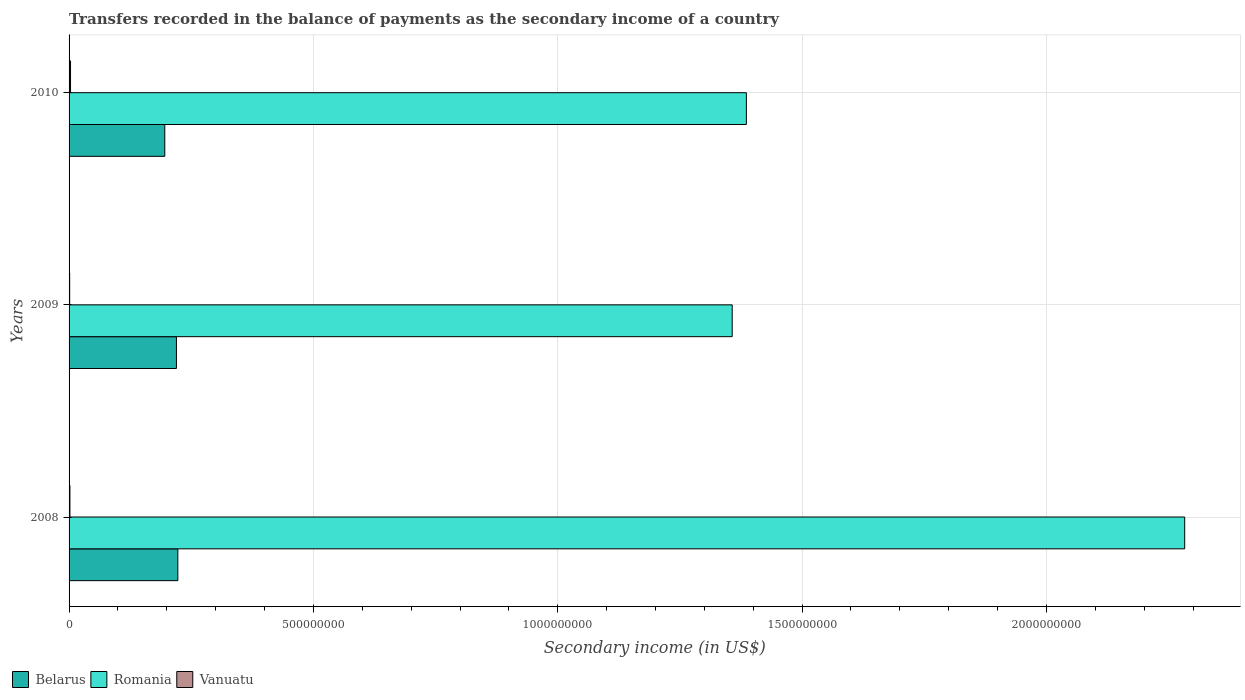How many groups of bars are there?
Give a very brief answer. 3. Are the number of bars per tick equal to the number of legend labels?
Your answer should be compact. Yes. Are the number of bars on each tick of the Y-axis equal?
Provide a short and direct response. Yes. How many bars are there on the 3rd tick from the top?
Provide a short and direct response. 3. What is the label of the 3rd group of bars from the top?
Ensure brevity in your answer.  2008. What is the secondary income of in Romania in 2008?
Your answer should be compact. 2.28e+09. Across all years, what is the maximum secondary income of in Vanuatu?
Your answer should be compact. 2.99e+06. Across all years, what is the minimum secondary income of in Vanuatu?
Offer a very short reply. 1.23e+06. In which year was the secondary income of in Romania maximum?
Provide a short and direct response. 2008. What is the total secondary income of in Romania in the graph?
Make the answer very short. 5.03e+09. What is the difference between the secondary income of in Vanuatu in 2008 and that in 2010?
Keep it short and to the point. -1.26e+06. What is the difference between the secondary income of in Vanuatu in 2009 and the secondary income of in Belarus in 2008?
Your answer should be very brief. -2.21e+08. What is the average secondary income of in Romania per year?
Make the answer very short. 1.68e+09. In the year 2008, what is the difference between the secondary income of in Romania and secondary income of in Belarus?
Ensure brevity in your answer.  2.06e+09. What is the ratio of the secondary income of in Vanuatu in 2008 to that in 2009?
Your answer should be very brief. 1.41. Is the difference between the secondary income of in Romania in 2008 and 2010 greater than the difference between the secondary income of in Belarus in 2008 and 2010?
Make the answer very short. Yes. What is the difference between the highest and the second highest secondary income of in Belarus?
Offer a very short reply. 2.90e+06. What is the difference between the highest and the lowest secondary income of in Vanuatu?
Offer a very short reply. 1.77e+06. In how many years, is the secondary income of in Vanuatu greater than the average secondary income of in Vanuatu taken over all years?
Give a very brief answer. 1. What does the 2nd bar from the top in 2009 represents?
Give a very brief answer. Romania. What does the 2nd bar from the bottom in 2009 represents?
Offer a terse response. Romania. Is it the case that in every year, the sum of the secondary income of in Romania and secondary income of in Belarus is greater than the secondary income of in Vanuatu?
Your response must be concise. Yes. How many years are there in the graph?
Ensure brevity in your answer.  3. What is the difference between two consecutive major ticks on the X-axis?
Offer a very short reply. 5.00e+08. Are the values on the major ticks of X-axis written in scientific E-notation?
Ensure brevity in your answer.  No. Does the graph contain any zero values?
Ensure brevity in your answer.  No. Does the graph contain grids?
Provide a succinct answer. Yes. Where does the legend appear in the graph?
Make the answer very short. Bottom left. How many legend labels are there?
Your answer should be compact. 3. What is the title of the graph?
Make the answer very short. Transfers recorded in the balance of payments as the secondary income of a country. Does "European Union" appear as one of the legend labels in the graph?
Offer a very short reply. No. What is the label or title of the X-axis?
Your answer should be very brief. Secondary income (in US$). What is the Secondary income (in US$) of Belarus in 2008?
Ensure brevity in your answer.  2.23e+08. What is the Secondary income (in US$) in Romania in 2008?
Offer a terse response. 2.28e+09. What is the Secondary income (in US$) in Vanuatu in 2008?
Provide a succinct answer. 1.73e+06. What is the Secondary income (in US$) in Belarus in 2009?
Offer a very short reply. 2.20e+08. What is the Secondary income (in US$) in Romania in 2009?
Provide a succinct answer. 1.36e+09. What is the Secondary income (in US$) in Vanuatu in 2009?
Ensure brevity in your answer.  1.23e+06. What is the Secondary income (in US$) in Belarus in 2010?
Provide a short and direct response. 1.96e+08. What is the Secondary income (in US$) in Romania in 2010?
Offer a terse response. 1.39e+09. What is the Secondary income (in US$) in Vanuatu in 2010?
Your response must be concise. 2.99e+06. Across all years, what is the maximum Secondary income (in US$) of Belarus?
Give a very brief answer. 2.23e+08. Across all years, what is the maximum Secondary income (in US$) of Romania?
Your answer should be compact. 2.28e+09. Across all years, what is the maximum Secondary income (in US$) of Vanuatu?
Provide a succinct answer. 2.99e+06. Across all years, what is the minimum Secondary income (in US$) of Belarus?
Ensure brevity in your answer.  1.96e+08. Across all years, what is the minimum Secondary income (in US$) in Romania?
Offer a very short reply. 1.36e+09. Across all years, what is the minimum Secondary income (in US$) of Vanuatu?
Your response must be concise. 1.23e+06. What is the total Secondary income (in US$) of Belarus in the graph?
Give a very brief answer. 6.38e+08. What is the total Secondary income (in US$) of Romania in the graph?
Your answer should be compact. 5.03e+09. What is the total Secondary income (in US$) of Vanuatu in the graph?
Your answer should be compact. 5.96e+06. What is the difference between the Secondary income (in US$) of Belarus in 2008 and that in 2009?
Keep it short and to the point. 2.90e+06. What is the difference between the Secondary income (in US$) in Romania in 2008 and that in 2009?
Offer a very short reply. 9.26e+08. What is the difference between the Secondary income (in US$) in Vanuatu in 2008 and that in 2009?
Give a very brief answer. 5.06e+05. What is the difference between the Secondary income (in US$) of Belarus in 2008 and that in 2010?
Your response must be concise. 2.67e+07. What is the difference between the Secondary income (in US$) in Romania in 2008 and that in 2010?
Your response must be concise. 8.97e+08. What is the difference between the Secondary income (in US$) in Vanuatu in 2008 and that in 2010?
Provide a short and direct response. -1.26e+06. What is the difference between the Secondary income (in US$) in Belarus in 2009 and that in 2010?
Offer a terse response. 2.38e+07. What is the difference between the Secondary income (in US$) in Romania in 2009 and that in 2010?
Your response must be concise. -2.90e+07. What is the difference between the Secondary income (in US$) of Vanuatu in 2009 and that in 2010?
Offer a terse response. -1.77e+06. What is the difference between the Secondary income (in US$) in Belarus in 2008 and the Secondary income (in US$) in Romania in 2009?
Your answer should be compact. -1.13e+09. What is the difference between the Secondary income (in US$) in Belarus in 2008 and the Secondary income (in US$) in Vanuatu in 2009?
Keep it short and to the point. 2.21e+08. What is the difference between the Secondary income (in US$) of Romania in 2008 and the Secondary income (in US$) of Vanuatu in 2009?
Provide a succinct answer. 2.28e+09. What is the difference between the Secondary income (in US$) in Belarus in 2008 and the Secondary income (in US$) in Romania in 2010?
Ensure brevity in your answer.  -1.16e+09. What is the difference between the Secondary income (in US$) of Belarus in 2008 and the Secondary income (in US$) of Vanuatu in 2010?
Make the answer very short. 2.20e+08. What is the difference between the Secondary income (in US$) of Romania in 2008 and the Secondary income (in US$) of Vanuatu in 2010?
Provide a succinct answer. 2.28e+09. What is the difference between the Secondary income (in US$) of Belarus in 2009 and the Secondary income (in US$) of Romania in 2010?
Provide a succinct answer. -1.17e+09. What is the difference between the Secondary income (in US$) of Belarus in 2009 and the Secondary income (in US$) of Vanuatu in 2010?
Give a very brief answer. 2.17e+08. What is the difference between the Secondary income (in US$) of Romania in 2009 and the Secondary income (in US$) of Vanuatu in 2010?
Make the answer very short. 1.35e+09. What is the average Secondary income (in US$) of Belarus per year?
Keep it short and to the point. 2.13e+08. What is the average Secondary income (in US$) in Romania per year?
Keep it short and to the point. 1.68e+09. What is the average Secondary income (in US$) in Vanuatu per year?
Keep it short and to the point. 1.99e+06. In the year 2008, what is the difference between the Secondary income (in US$) in Belarus and Secondary income (in US$) in Romania?
Give a very brief answer. -2.06e+09. In the year 2008, what is the difference between the Secondary income (in US$) in Belarus and Secondary income (in US$) in Vanuatu?
Offer a terse response. 2.21e+08. In the year 2008, what is the difference between the Secondary income (in US$) of Romania and Secondary income (in US$) of Vanuatu?
Offer a terse response. 2.28e+09. In the year 2009, what is the difference between the Secondary income (in US$) in Belarus and Secondary income (in US$) in Romania?
Your response must be concise. -1.14e+09. In the year 2009, what is the difference between the Secondary income (in US$) in Belarus and Secondary income (in US$) in Vanuatu?
Provide a short and direct response. 2.18e+08. In the year 2009, what is the difference between the Secondary income (in US$) of Romania and Secondary income (in US$) of Vanuatu?
Make the answer very short. 1.36e+09. In the year 2010, what is the difference between the Secondary income (in US$) of Belarus and Secondary income (in US$) of Romania?
Provide a succinct answer. -1.19e+09. In the year 2010, what is the difference between the Secondary income (in US$) of Belarus and Secondary income (in US$) of Vanuatu?
Offer a terse response. 1.93e+08. In the year 2010, what is the difference between the Secondary income (in US$) in Romania and Secondary income (in US$) in Vanuatu?
Offer a terse response. 1.38e+09. What is the ratio of the Secondary income (in US$) of Belarus in 2008 to that in 2009?
Provide a short and direct response. 1.01. What is the ratio of the Secondary income (in US$) in Romania in 2008 to that in 2009?
Provide a succinct answer. 1.68. What is the ratio of the Secondary income (in US$) of Vanuatu in 2008 to that in 2009?
Provide a succinct answer. 1.41. What is the ratio of the Secondary income (in US$) of Belarus in 2008 to that in 2010?
Give a very brief answer. 1.14. What is the ratio of the Secondary income (in US$) of Romania in 2008 to that in 2010?
Provide a short and direct response. 1.65. What is the ratio of the Secondary income (in US$) of Vanuatu in 2008 to that in 2010?
Provide a succinct answer. 0.58. What is the ratio of the Secondary income (in US$) in Belarus in 2009 to that in 2010?
Offer a very short reply. 1.12. What is the ratio of the Secondary income (in US$) in Romania in 2009 to that in 2010?
Keep it short and to the point. 0.98. What is the ratio of the Secondary income (in US$) of Vanuatu in 2009 to that in 2010?
Offer a very short reply. 0.41. What is the difference between the highest and the second highest Secondary income (in US$) of Belarus?
Your response must be concise. 2.90e+06. What is the difference between the highest and the second highest Secondary income (in US$) of Romania?
Make the answer very short. 8.97e+08. What is the difference between the highest and the second highest Secondary income (in US$) in Vanuatu?
Offer a very short reply. 1.26e+06. What is the difference between the highest and the lowest Secondary income (in US$) of Belarus?
Keep it short and to the point. 2.67e+07. What is the difference between the highest and the lowest Secondary income (in US$) in Romania?
Your answer should be very brief. 9.26e+08. What is the difference between the highest and the lowest Secondary income (in US$) of Vanuatu?
Your response must be concise. 1.77e+06. 